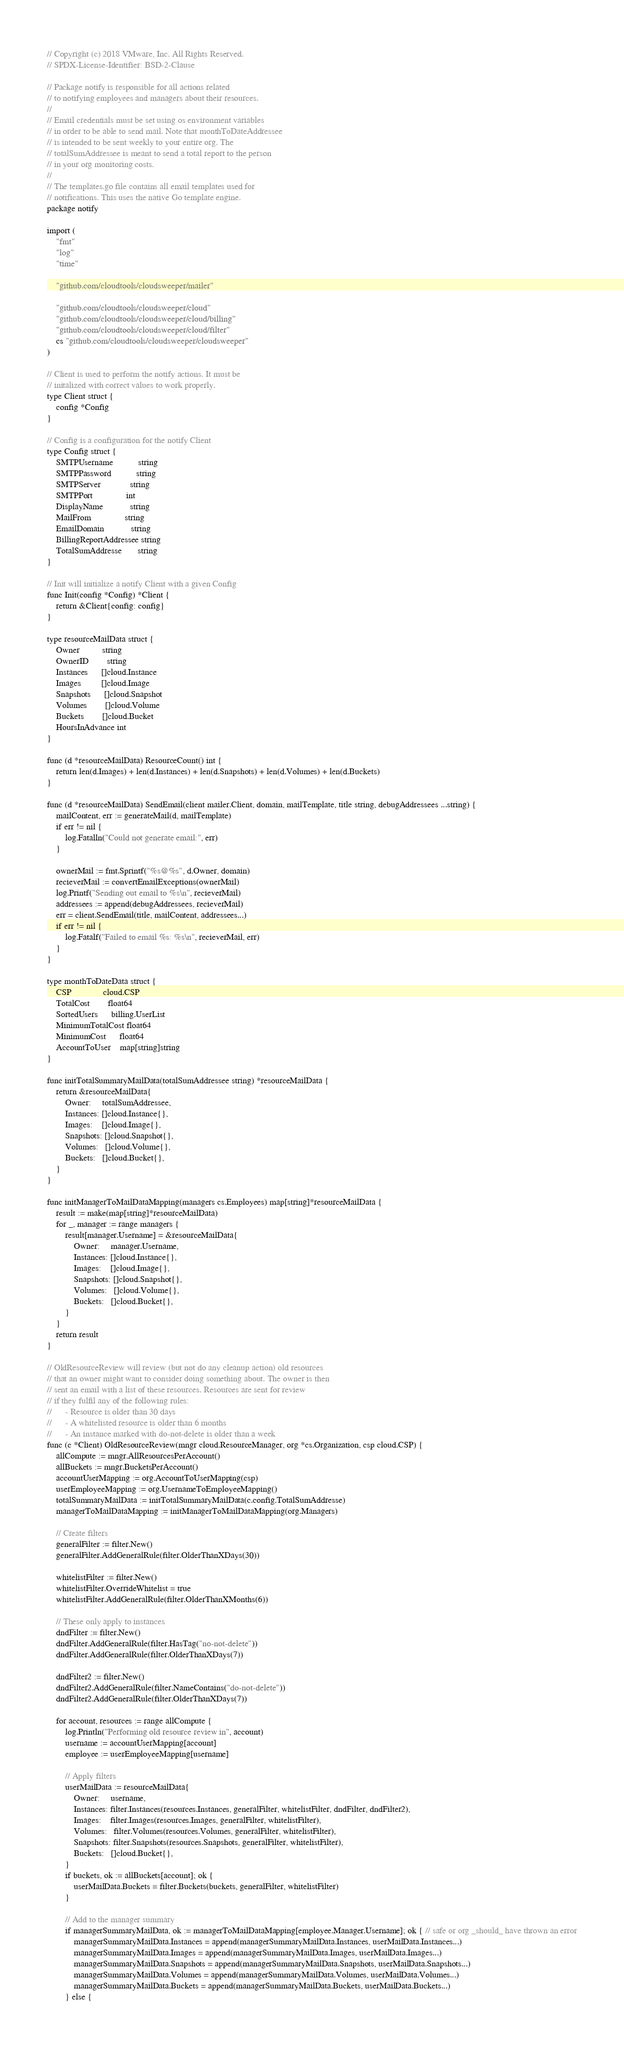Convert code to text. <code><loc_0><loc_0><loc_500><loc_500><_Go_>// Copyright (c) 2018 VMware, Inc. All Rights Reserved.
// SPDX-License-Identifier: BSD-2-Clause

// Package notify is responsible for all actions related
// to notifying employees and managers about their resources.
//
// Email credentials must be set using os environment variables
// in order to be able to send mail. Note that monthToDateAddressee
// is intended to be sent weekly to your entire org. The
// totalSumAddressee is meant to send a total report to the person
// in your org monitoring costs.
//
// The templates.go file contains all email templates used for
// notifications. This uses the native Go template engine.
package notify

import (
	"fmt"
	"log"
	"time"

	"github.com/cloudtools/cloudsweeper/mailer"

	"github.com/cloudtools/cloudsweeper/cloud"
	"github.com/cloudtools/cloudsweeper/cloud/billing"
	"github.com/cloudtools/cloudsweeper/cloud/filter"
	cs "github.com/cloudtools/cloudsweeper/cloudsweeper"
)

// Client is used to perform the notify actions. It must be
// initalized with correct values to work properly.
type Client struct {
	config *Config
}

// Config is a configuration for the notify Client
type Config struct {
	SMTPUsername           string
	SMTPPassword           string
	SMTPServer             string
	SMTPPort               int
	DisplayName            string
	MailFrom               string
	EmailDomain            string
	BillingReportAddressee string
	TotalSumAddresse       string
}

// Init will initialize a notify Client with a given Config
func Init(config *Config) *Client {
	return &Client{config: config}
}

type resourceMailData struct {
	Owner          string
	OwnerID        string
	Instances      []cloud.Instance
	Images         []cloud.Image
	Snapshots      []cloud.Snapshot
	Volumes        []cloud.Volume
	Buckets        []cloud.Bucket
	HoursInAdvance int
}

func (d *resourceMailData) ResourceCount() int {
	return len(d.Images) + len(d.Instances) + len(d.Snapshots) + len(d.Volumes) + len(d.Buckets)
}

func (d *resourceMailData) SendEmail(client mailer.Client, domain, mailTemplate, title string, debugAddressees ...string) {
	mailContent, err := generateMail(d, mailTemplate)
	if err != nil {
		log.Fatalln("Could not generate email:", err)
	}

	ownerMail := fmt.Sprintf("%s@%s", d.Owner, domain)
	recieverMail := convertEmailExceptions(ownerMail)
	log.Printf("Sending out email to %s\n", recieverMail)
	addressees := append(debugAddressees, recieverMail)
	err = client.SendEmail(title, mailContent, addressees...)
	if err != nil {
		log.Fatalf("Failed to email %s: %s\n", recieverMail, err)
	}
}

type monthToDateData struct {
	CSP              cloud.CSP
	TotalCost        float64
	SortedUsers      billing.UserList
	MinimumTotalCost float64
	MinimumCost      float64
	AccountToUser    map[string]string
}

func initTotalSummaryMailData(totalSumAddressee string) *resourceMailData {
	return &resourceMailData{
		Owner:     totalSumAddressee,
		Instances: []cloud.Instance{},
		Images:    []cloud.Image{},
		Snapshots: []cloud.Snapshot{},
		Volumes:   []cloud.Volume{},
		Buckets:   []cloud.Bucket{},
	}
}

func initManagerToMailDataMapping(managers cs.Employees) map[string]*resourceMailData {
	result := make(map[string]*resourceMailData)
	for _, manager := range managers {
		result[manager.Username] = &resourceMailData{
			Owner:     manager.Username,
			Instances: []cloud.Instance{},
			Images:    []cloud.Image{},
			Snapshots: []cloud.Snapshot{},
			Volumes:   []cloud.Volume{},
			Buckets:   []cloud.Bucket{},
		}
	}
	return result
}

// OldResourceReview will review (but not do any cleanup action) old resources
// that an owner might want to consider doing something about. The owner is then
// sent an email with a list of these resources. Resources are sent for review
// if they fulfil any of the following rules:
//		- Resource is older than 30 days
//		- A whitelisted resource is older than 6 months
//		- An instance marked with do-not-delete is older than a week
func (c *Client) OldResourceReview(mngr cloud.ResourceManager, org *cs.Organization, csp cloud.CSP) {
	allCompute := mngr.AllResourcesPerAccount()
	allBuckets := mngr.BucketsPerAccount()
	accountUserMapping := org.AccountToUserMapping(csp)
	userEmployeeMapping := org.UsernameToEmployeeMapping()
	totalSummaryMailData := initTotalSummaryMailData(c.config.TotalSumAddresse)
	managerToMailDataMapping := initManagerToMailDataMapping(org.Managers)

	// Create filters
	generalFilter := filter.New()
	generalFilter.AddGeneralRule(filter.OlderThanXDays(30))

	whitelistFilter := filter.New()
	whitelistFilter.OverrideWhitelist = true
	whitelistFilter.AddGeneralRule(filter.OlderThanXMonths(6))

	// These only apply to instances
	dndFilter := filter.New()
	dndFilter.AddGeneralRule(filter.HasTag("no-not-delete"))
	dndFilter.AddGeneralRule(filter.OlderThanXDays(7))

	dndFilter2 := filter.New()
	dndFilter2.AddGeneralRule(filter.NameContains("do-not-delete"))
	dndFilter2.AddGeneralRule(filter.OlderThanXDays(7))

	for account, resources := range allCompute {
		log.Println("Performing old resource review in", account)
		username := accountUserMapping[account]
		employee := userEmployeeMapping[username]

		// Apply filters
		userMailData := resourceMailData{
			Owner:     username,
			Instances: filter.Instances(resources.Instances, generalFilter, whitelistFilter, dndFilter, dndFilter2),
			Images:    filter.Images(resources.Images, generalFilter, whitelistFilter),
			Volumes:   filter.Volumes(resources.Volumes, generalFilter, whitelistFilter),
			Snapshots: filter.Snapshots(resources.Snapshots, generalFilter, whitelistFilter),
			Buckets:   []cloud.Bucket{},
		}
		if buckets, ok := allBuckets[account]; ok {
			userMailData.Buckets = filter.Buckets(buckets, generalFilter, whitelistFilter)
		}

		// Add to the manager summary
		if managerSummaryMailData, ok := managerToMailDataMapping[employee.Manager.Username]; ok { // safe or org _should_ have thrown an error
			managerSummaryMailData.Instances = append(managerSummaryMailData.Instances, userMailData.Instances...)
			managerSummaryMailData.Images = append(managerSummaryMailData.Images, userMailData.Images...)
			managerSummaryMailData.Snapshots = append(managerSummaryMailData.Snapshots, userMailData.Snapshots...)
			managerSummaryMailData.Volumes = append(managerSummaryMailData.Volumes, userMailData.Volumes...)
			managerSummaryMailData.Buckets = append(managerSummaryMailData.Buckets, userMailData.Buckets...)
		} else {</code> 